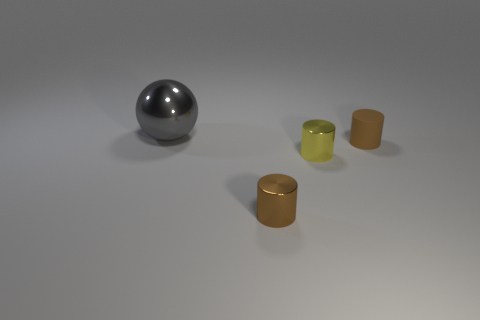Are there any other things that have the same size as the gray thing?
Your answer should be very brief. No. There is a thing that is behind the tiny brown object on the right side of the yellow metal cylinder; what is it made of?
Make the answer very short. Metal. There is a thing that is behind the tiny yellow shiny cylinder and on the right side of the gray object; what color is it?
Keep it short and to the point. Brown. How many other objects are there of the same size as the yellow metal object?
Your answer should be compact. 2. There is a yellow object; does it have the same size as the sphere that is behind the yellow object?
Make the answer very short. No. What is the color of the other matte cylinder that is the same size as the yellow cylinder?
Offer a terse response. Brown. What is the size of the metal sphere?
Your answer should be compact. Large. Is the brown object to the right of the tiny yellow shiny object made of the same material as the gray thing?
Keep it short and to the point. No. Do the brown rubber object and the big metal thing have the same shape?
Make the answer very short. No. There is a tiny brown thing that is behind the tiny metal cylinder that is behind the cylinder in front of the yellow shiny object; what is its shape?
Your answer should be very brief. Cylinder. 